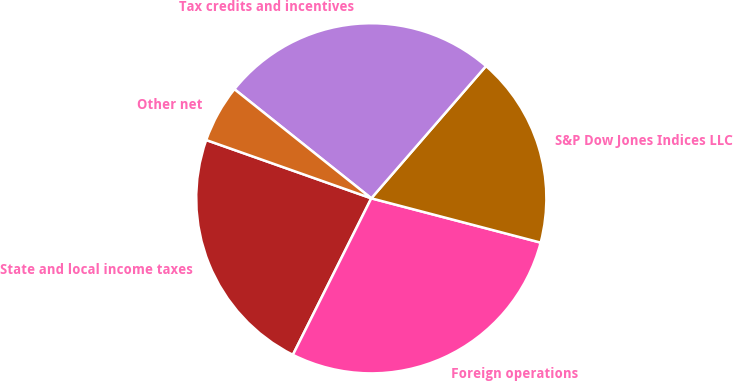<chart> <loc_0><loc_0><loc_500><loc_500><pie_chart><fcel>State and local income taxes<fcel>Foreign operations<fcel>S&P Dow Jones Indices LLC<fcel>Tax credits and incentives<fcel>Other net<nl><fcel>23.01%<fcel>28.32%<fcel>17.7%<fcel>25.66%<fcel>5.31%<nl></chart> 